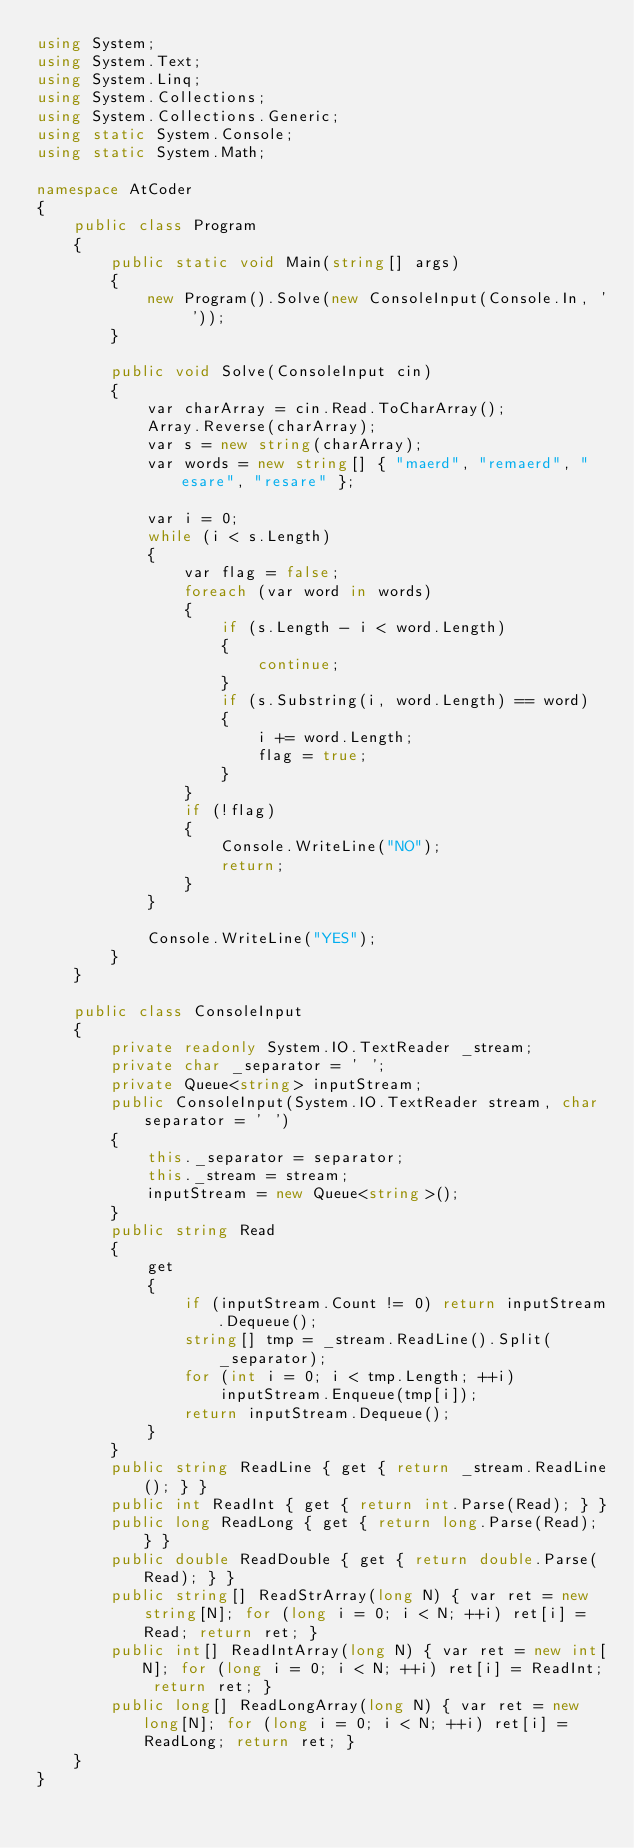Convert code to text. <code><loc_0><loc_0><loc_500><loc_500><_C#_>using System;
using System.Text;
using System.Linq;
using System.Collections;
using System.Collections.Generic;
using static System.Console;
using static System.Math;

namespace AtCoder
{
    public class Program
    {
        public static void Main(string[] args)
        {
            new Program().Solve(new ConsoleInput(Console.In, ' '));
        }

        public void Solve(ConsoleInput cin)
        {
            var charArray = cin.Read.ToCharArray();
            Array.Reverse(charArray);
            var s = new string(charArray);
            var words = new string[] { "maerd", "remaerd", "esare", "resare" };

            var i = 0;
            while (i < s.Length)
            {
                var flag = false;
                foreach (var word in words)
                {
                    if (s.Length - i < word.Length)
                    {
                        continue;
                    }
                    if (s.Substring(i, word.Length) == word)
                    {
                        i += word.Length;
                        flag = true;
                    }
                }
                if (!flag)
                {
                    Console.WriteLine("NO");
                    return;
                }
            }

            Console.WriteLine("YES");
        }
    }

    public class ConsoleInput
    {
        private readonly System.IO.TextReader _stream;
        private char _separator = ' ';
        private Queue<string> inputStream;
        public ConsoleInput(System.IO.TextReader stream, char separator = ' ')
        {
            this._separator = separator;
            this._stream = stream;
            inputStream = new Queue<string>();
        }
        public string Read
        {
            get
            {
                if (inputStream.Count != 0) return inputStream.Dequeue();
                string[] tmp = _stream.ReadLine().Split(_separator);
                for (int i = 0; i < tmp.Length; ++i)
                    inputStream.Enqueue(tmp[i]);
                return inputStream.Dequeue();
            }
        }
        public string ReadLine { get { return _stream.ReadLine(); } }
        public int ReadInt { get { return int.Parse(Read); } }
        public long ReadLong { get { return long.Parse(Read); } }
        public double ReadDouble { get { return double.Parse(Read); } }
        public string[] ReadStrArray(long N) { var ret = new string[N]; for (long i = 0; i < N; ++i) ret[i] = Read; return ret; }
        public int[] ReadIntArray(long N) { var ret = new int[N]; for (long i = 0; i < N; ++i) ret[i] = ReadInt; return ret; }
        public long[] ReadLongArray(long N) { var ret = new long[N]; for (long i = 0; i < N; ++i) ret[i] = ReadLong; return ret; }
    }
}</code> 